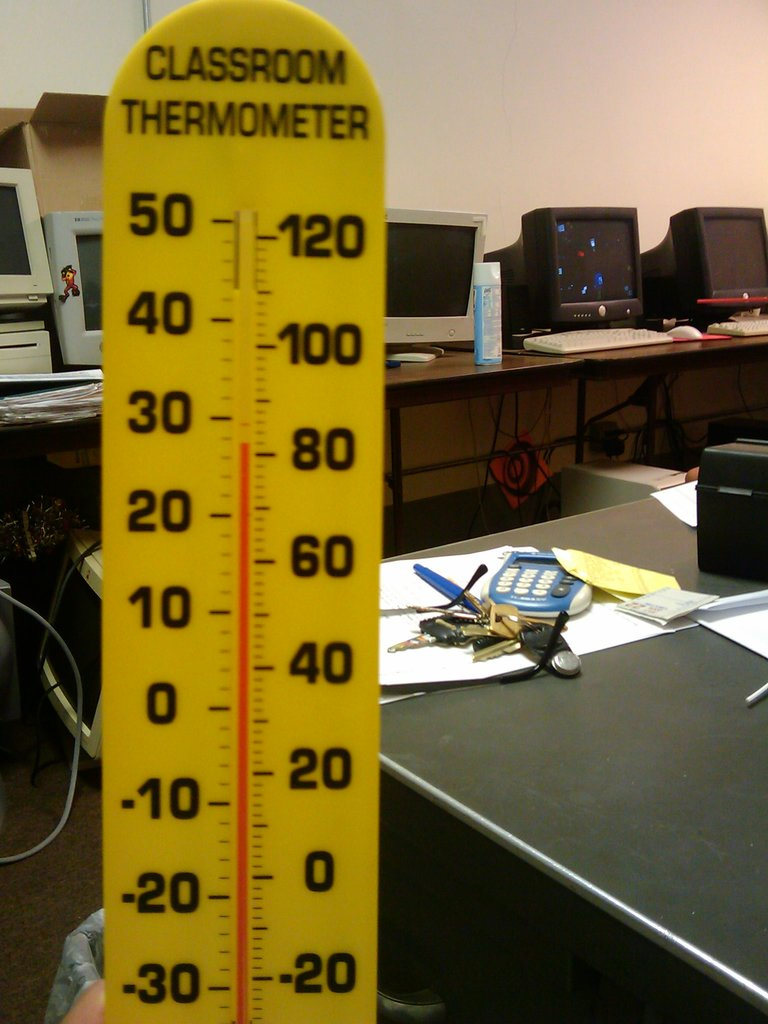What do you see happening in this image?
 The image captures a scene in what appears to be a classroom or office setting. Dominating the foreground is a yellow classroom thermometer, marked with red numbers ranging from -30 to 50. The text "CLASSROOM THERMOMETER" is clearly visible at the top of the thermometer. The background reveals a desk cluttered with various items, including a calculator, papers, and computer monitors, suggesting a busy work environment. 